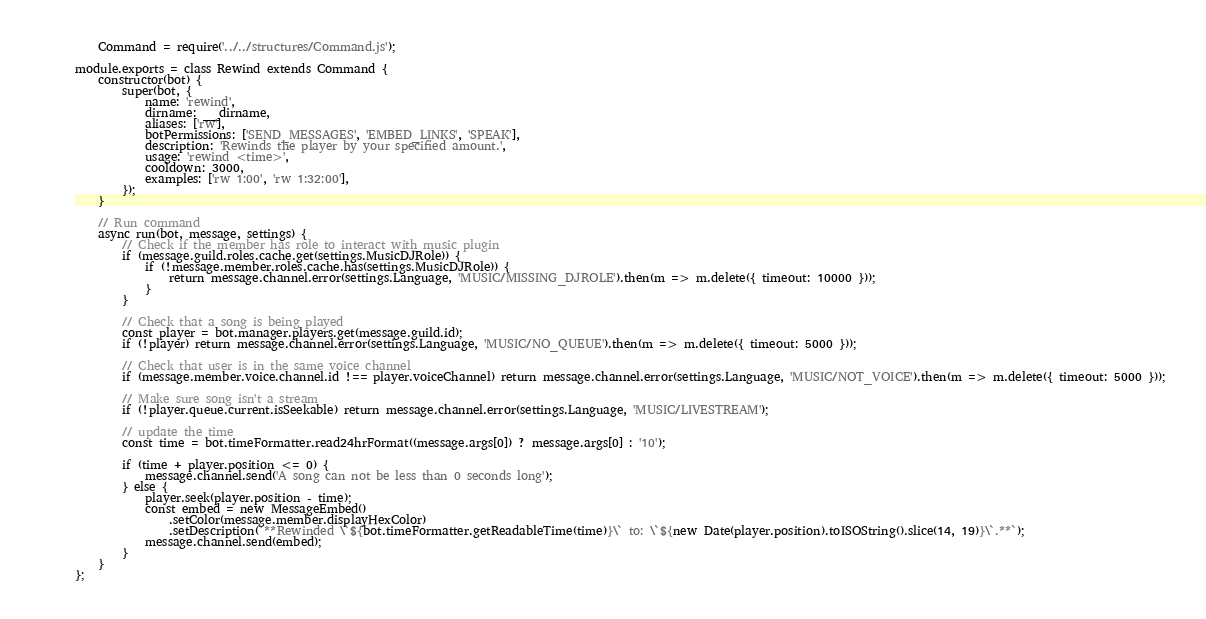<code> <loc_0><loc_0><loc_500><loc_500><_JavaScript_>	Command = require('../../structures/Command.js');

module.exports = class Rewind extends Command {
	constructor(bot) {
		super(bot, {
			name: 'rewind',
			dirname: __dirname,
			aliases: ['rw'],
			botPermissions: ['SEND_MESSAGES', 'EMBED_LINKS', 'SPEAK'],
			description: 'Rewinds the player by your specified amount.',
			usage: 'rewind <time>',
			cooldown: 3000,
			examples: ['rw 1:00', 'rw 1:32:00'],
		});
	}

	// Run command
	async run(bot, message, settings) {
		// Check if the member has role to interact with music plugin
		if (message.guild.roles.cache.get(settings.MusicDJRole)) {
			if (!message.member.roles.cache.has(settings.MusicDJRole)) {
				return message.channel.error(settings.Language, 'MUSIC/MISSING_DJROLE').then(m => m.delete({ timeout: 10000 }));
			}
		}

		// Check that a song is being played
		const player = bot.manager.players.get(message.guild.id);
		if (!player) return message.channel.error(settings.Language, 'MUSIC/NO_QUEUE').then(m => m.delete({ timeout: 5000 }));

		// Check that user is in the same voice channel
		if (message.member.voice.channel.id !== player.voiceChannel) return message.channel.error(settings.Language, 'MUSIC/NOT_VOICE').then(m => m.delete({ timeout: 5000 }));

		// Make sure song isn't a stream
		if (!player.queue.current.isSeekable) return message.channel.error(settings.Language, 'MUSIC/LIVESTREAM');

		// update the time
		const time = bot.timeFormatter.read24hrFormat((message.args[0]) ? message.args[0] : '10');

		if (time + player.position <= 0) {
			message.channel.send('A song can not be less than 0 seconds long');
		} else {
			player.seek(player.position - time);
			const embed = new MessageEmbed()
				.setColor(message.member.displayHexColor)
				.setDescription(`**Rewinded \`${bot.timeFormatter.getReadableTime(time)}\` to: \`${new Date(player.position).toISOString().slice(14, 19)}\`.**`);
			message.channel.send(embed);
		}
	}
};
</code> 